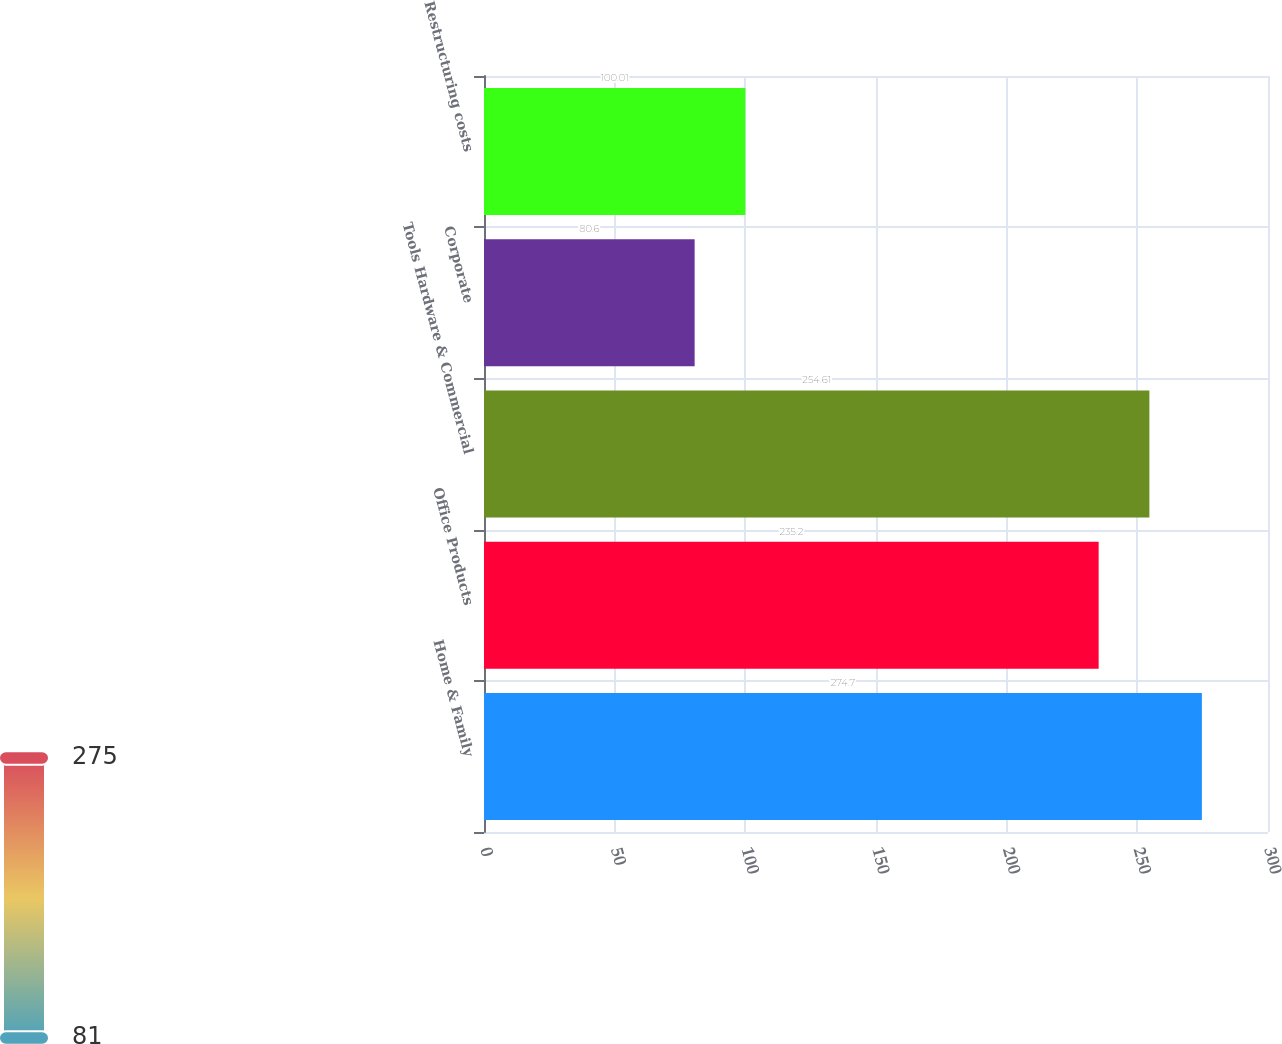Convert chart to OTSL. <chart><loc_0><loc_0><loc_500><loc_500><bar_chart><fcel>Home & Family<fcel>Office Products<fcel>Tools Hardware & Commercial<fcel>Corporate<fcel>Restructuring costs<nl><fcel>274.7<fcel>235.2<fcel>254.61<fcel>80.6<fcel>100.01<nl></chart> 